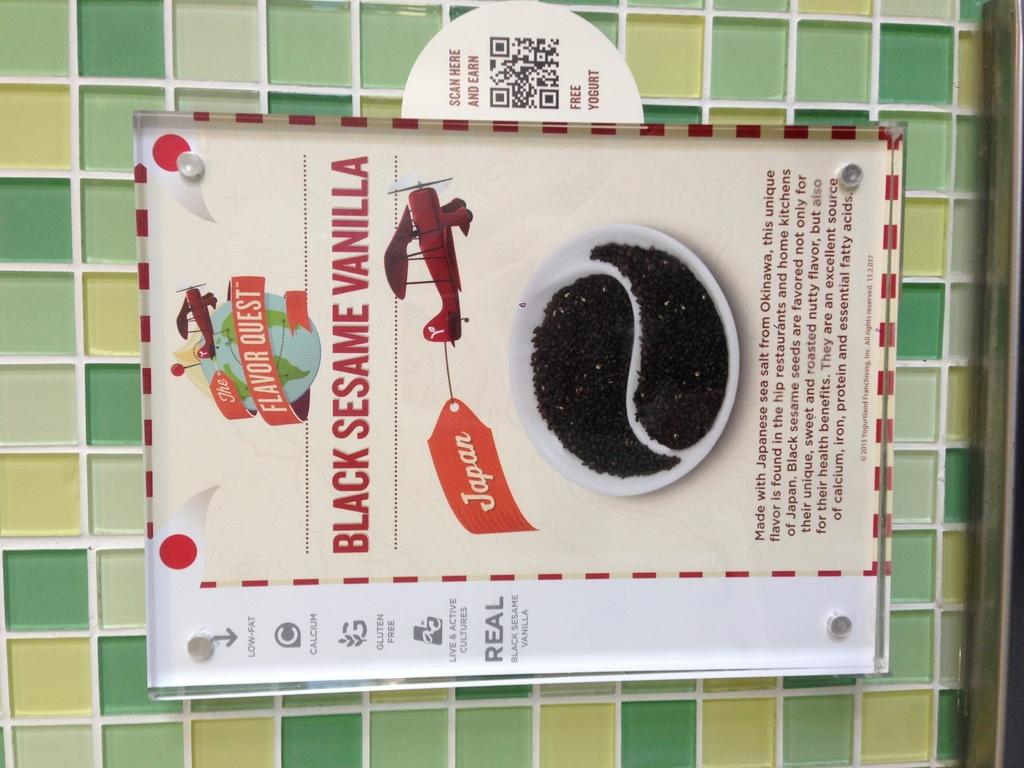<image>
Offer a succinct explanation of the picture presented. Sign on a wall that says Black Sesame Vanilla and shows an airplane. 